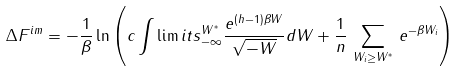<formula> <loc_0><loc_0><loc_500><loc_500>\Delta F ^ { i m } = - \frac { 1 } { \beta } \ln \left ( c \int \lim i t s _ { - \infty } ^ { W ^ { * } } \frac { e ^ { ( h - 1 ) \beta W } } { \sqrt { - W } } d W + \frac { 1 } { n } \, \sum _ { W _ { i } \geq W ^ { * } } \, e ^ { - \beta W _ { i } } \right )</formula> 